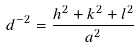Convert formula to latex. <formula><loc_0><loc_0><loc_500><loc_500>d ^ { - 2 } = \frac { h ^ { 2 } + k ^ { 2 } + l ^ { 2 } } { a ^ { 2 } }</formula> 